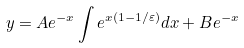<formula> <loc_0><loc_0><loc_500><loc_500>y = A e ^ { - x } \int e ^ { x \left ( 1 - 1 / \varepsilon \right ) } d x + B e ^ { - x }</formula> 